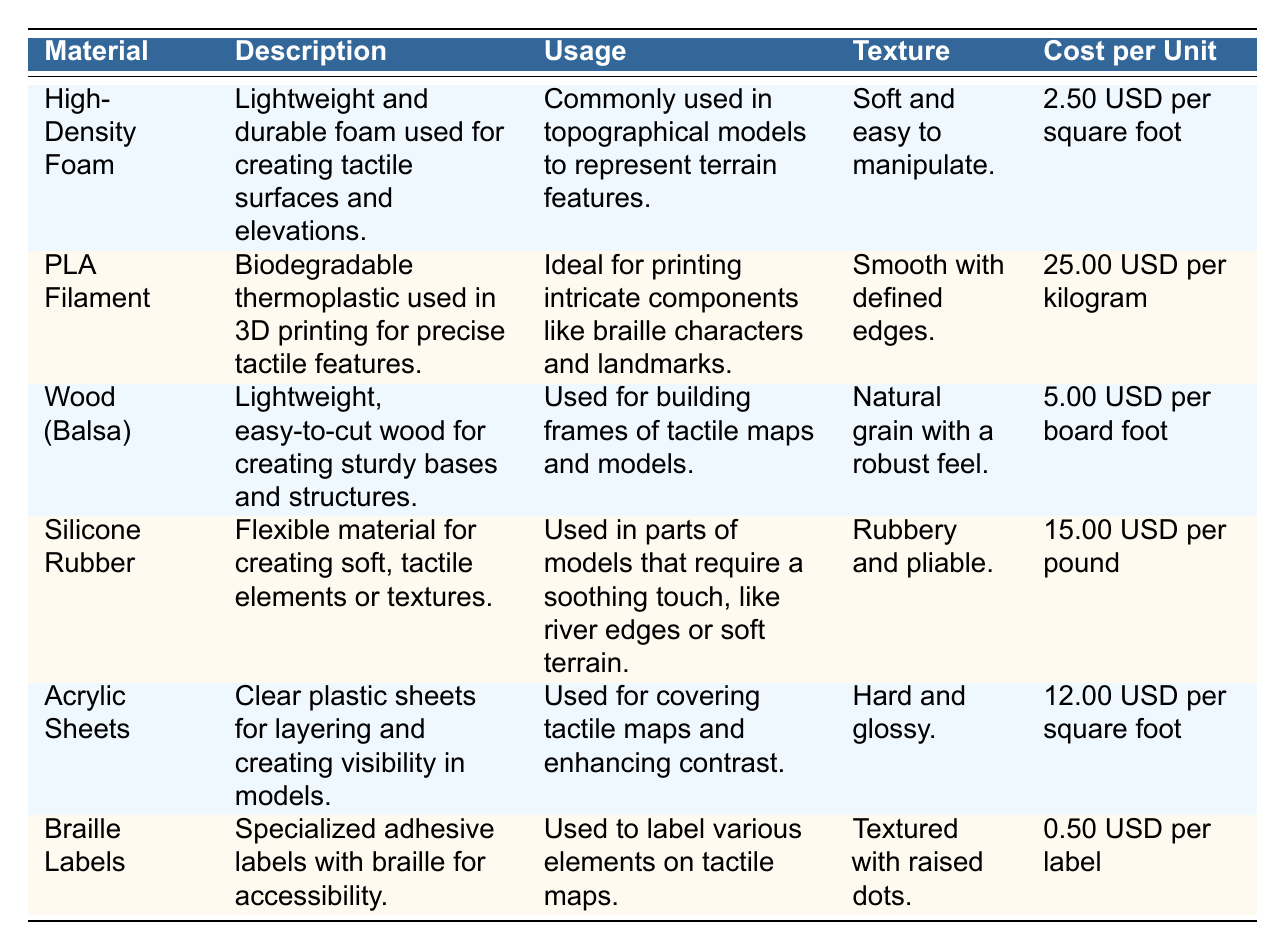What material is commonly used in topographical models? According to the table, "High-Density Foam" is mentioned in the usage section as being "Commonly used in topographical models to represent terrain features."
Answer: High-Density Foam What is the cost per unit of Braille Labels? The table provides the cost per unit for Braille Labels as "0.50 USD per label."
Answer: 0.50 USD per label Which material has a smooth texture with defined edges? The table describes "PLA Filament" as having a "Smooth with defined edges" texture, indicating it fits the criteria.
Answer: PLA Filament What is the average cost per unit of the materials listed? To find the average cost, we first list the costs: 2.50, 25.00, 5.00, 15.00, 12.00, 0.50 USD. Summing these gives 60.00 USD. Then, dividing by 6 (number of materials) results in approximately 10.00 USD.
Answer: 10.00 USD Is Silicone Rubber used for building frames of tactile maps? The table states that "Silicone Rubber" is used for creating soft, tactile elements and not for building frames, which are mentioned under "Wood (Balsa)." Thus, the statement is false.
Answer: No Which material is described as having a texture that is rubbery and pliable? Referring to the table, the texture described for "Silicone Rubber" is "Rubbery and pliable," matching the question's description.
Answer: Silicone Rubber How many materials cost less than 5.00 USD per unit? The materials under 5.00 USD are "High-Density Foam" at 2.50 USD and "Braille Labels" at 0.50 USD, totaling 2 materials meeting this criterion.
Answer: 2 materials Which material is ideal for printing intricate components like braille characters? The table indicates that "PLA Filament" is "Ideal for printing intricate components like braille characters and landmarks," matching the question.
Answer: PLA Filament What is the combined cost per unit of High-Density Foam and Wood (Balsa)? The cost per unit of High-Density Foam is 2.50 USD, and Wood (Balsa) is 5.00 USD. Adding these together gives a total of 7.50 USD.
Answer: 7.50 USD 